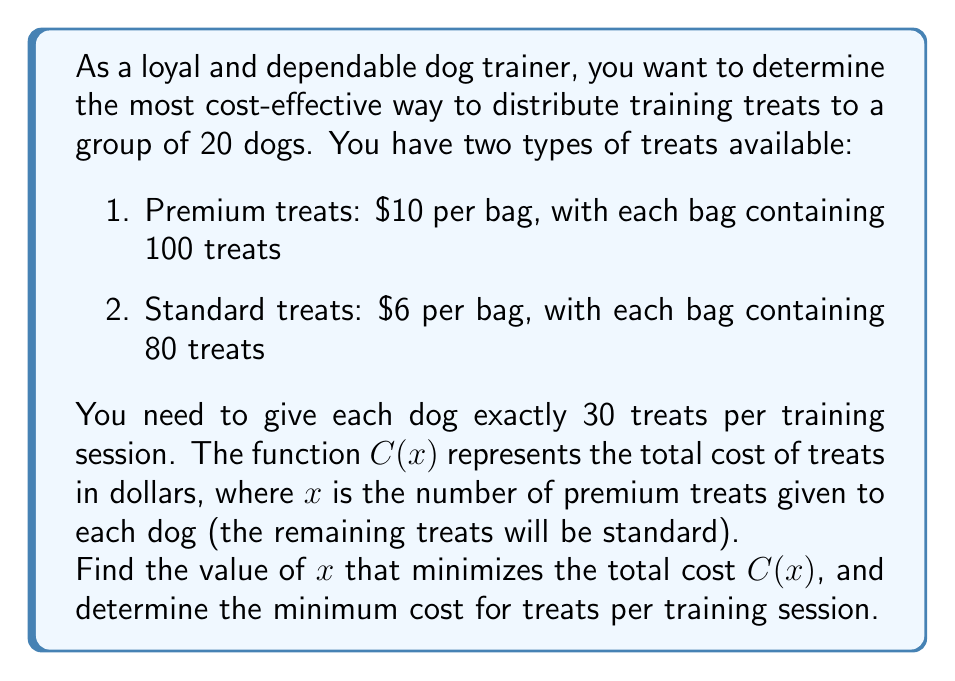Could you help me with this problem? Let's approach this step-by-step:

1) First, we need to express the total cost function $C(x)$ in terms of $x$.

2) For 20 dogs, with each dog getting 30 treats, we need a total of $20 \times 30 = 600$ treats.

3) If $x$ premium treats are given to each dog, then $(30-x)$ standard treats are given to each dog.

4) The number of premium treats needed: $20x$
   The number of standard treats needed: $20(30-x) = 600-20x$

5) Cost of premium treats: $\frac{20x}{100} \times \$10 = \$0.2x$
   Cost of standard treats: $\frac{600-20x}{80} \times \$6 = \$45 - \$1.5x$

6) Total cost function:
   $$C(x) = 0.2x + (45 - 1.5x) = 45 - 1.3x$$

7) To find the minimum cost, we need to consider the domain of $x$:
   $0 \leq x \leq 30$ (as we can't give negative treats or more than 30 premium treats per dog)

8) The function $C(x)$ is linear, so its minimum will occur at one of the endpoints of the domain.

9) Let's evaluate $C(x)$ at $x=0$ and $x=30$:
   $C(0) = 45 - 1.3(0) = 45$
   $C(30) = 45 - 1.3(30) = 6$

10) The minimum occurs at $x=30$, which means we should use only premium treats.

11) The minimum cost is $\$6$ per training session.
Answer: The most cost-effective distribution is to use only premium treats ($x=30$), resulting in a minimum cost of $\$6$ per training session. 